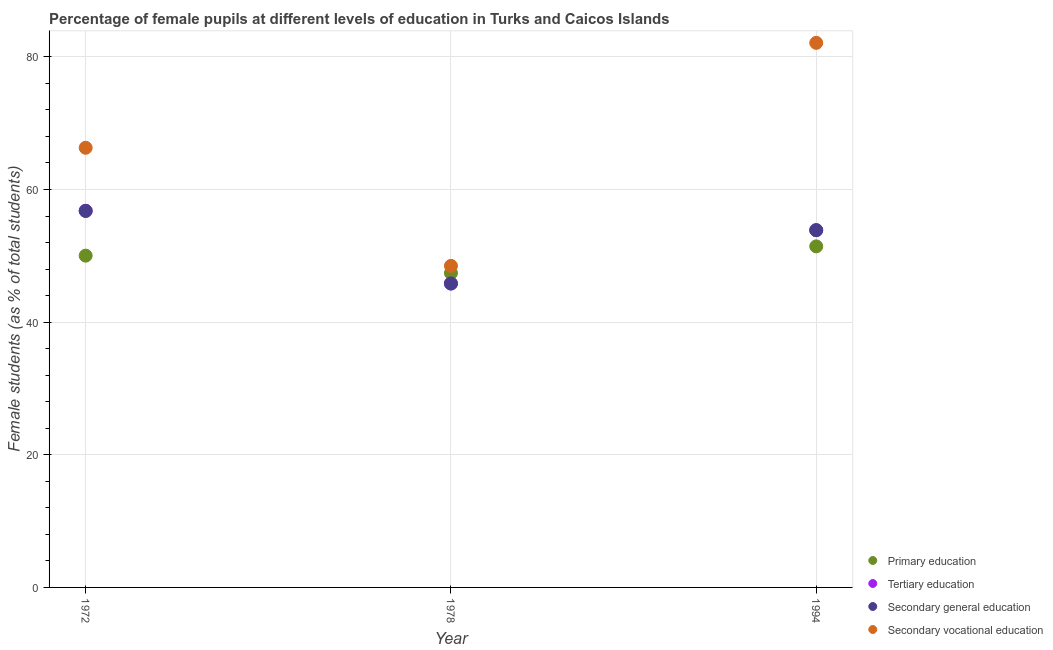How many different coloured dotlines are there?
Make the answer very short. 4. What is the percentage of female students in primary education in 1994?
Keep it short and to the point. 51.43. Across all years, what is the maximum percentage of female students in tertiary education?
Make the answer very short. 56.78. Across all years, what is the minimum percentage of female students in primary education?
Your response must be concise. 47.4. In which year was the percentage of female students in tertiary education minimum?
Offer a very short reply. 1978. What is the total percentage of female students in tertiary education in the graph?
Give a very brief answer. 156.47. What is the difference between the percentage of female students in tertiary education in 1972 and that in 1978?
Offer a very short reply. 10.96. What is the difference between the percentage of female students in tertiary education in 1978 and the percentage of female students in secondary education in 1994?
Your response must be concise. -8.04. What is the average percentage of female students in tertiary education per year?
Your response must be concise. 52.16. In the year 1994, what is the difference between the percentage of female students in primary education and percentage of female students in secondary education?
Make the answer very short. -2.44. In how many years, is the percentage of female students in secondary education greater than 64 %?
Make the answer very short. 0. What is the ratio of the percentage of female students in secondary education in 1972 to that in 1978?
Your response must be concise. 1.24. Is the percentage of female students in primary education in 1978 less than that in 1994?
Your answer should be compact. Yes. Is the difference between the percentage of female students in secondary vocational education in 1972 and 1978 greater than the difference between the percentage of female students in secondary education in 1972 and 1978?
Offer a terse response. Yes. What is the difference between the highest and the second highest percentage of female students in primary education?
Keep it short and to the point. 1.4. What is the difference between the highest and the lowest percentage of female students in primary education?
Keep it short and to the point. 4.03. Is the sum of the percentage of female students in primary education in 1978 and 1994 greater than the maximum percentage of female students in secondary vocational education across all years?
Your response must be concise. Yes. Is the percentage of female students in primary education strictly greater than the percentage of female students in secondary education over the years?
Provide a short and direct response. No. Is the percentage of female students in secondary education strictly less than the percentage of female students in tertiary education over the years?
Keep it short and to the point. No. How many dotlines are there?
Your response must be concise. 4. How many years are there in the graph?
Your response must be concise. 3. Are the values on the major ticks of Y-axis written in scientific E-notation?
Give a very brief answer. No. Does the graph contain any zero values?
Your response must be concise. No. What is the title of the graph?
Your response must be concise. Percentage of female pupils at different levels of education in Turks and Caicos Islands. What is the label or title of the X-axis?
Offer a terse response. Year. What is the label or title of the Y-axis?
Your answer should be compact. Female students (as % of total students). What is the Female students (as % of total students) in Primary education in 1972?
Offer a terse response. 50.03. What is the Female students (as % of total students) of Tertiary education in 1972?
Ensure brevity in your answer.  56.78. What is the Female students (as % of total students) of Secondary general education in 1972?
Your answer should be compact. 56.78. What is the Female students (as % of total students) in Secondary vocational education in 1972?
Offer a terse response. 66.29. What is the Female students (as % of total students) in Primary education in 1978?
Your response must be concise. 47.4. What is the Female students (as % of total students) of Tertiary education in 1978?
Offer a terse response. 45.82. What is the Female students (as % of total students) in Secondary general education in 1978?
Provide a succinct answer. 45.82. What is the Female students (as % of total students) of Secondary vocational education in 1978?
Give a very brief answer. 48.48. What is the Female students (as % of total students) of Primary education in 1994?
Provide a succinct answer. 51.43. What is the Female students (as % of total students) in Tertiary education in 1994?
Give a very brief answer. 53.87. What is the Female students (as % of total students) in Secondary general education in 1994?
Offer a very short reply. 53.87. What is the Female students (as % of total students) in Secondary vocational education in 1994?
Your answer should be very brief. 82.11. Across all years, what is the maximum Female students (as % of total students) of Primary education?
Give a very brief answer. 51.43. Across all years, what is the maximum Female students (as % of total students) of Tertiary education?
Your answer should be compact. 56.78. Across all years, what is the maximum Female students (as % of total students) of Secondary general education?
Provide a succinct answer. 56.78. Across all years, what is the maximum Female students (as % of total students) in Secondary vocational education?
Provide a succinct answer. 82.11. Across all years, what is the minimum Female students (as % of total students) of Primary education?
Your answer should be compact. 47.4. Across all years, what is the minimum Female students (as % of total students) in Tertiary education?
Give a very brief answer. 45.82. Across all years, what is the minimum Female students (as % of total students) in Secondary general education?
Offer a very short reply. 45.82. Across all years, what is the minimum Female students (as % of total students) of Secondary vocational education?
Offer a terse response. 48.48. What is the total Female students (as % of total students) in Primary education in the graph?
Offer a terse response. 148.86. What is the total Female students (as % of total students) of Tertiary education in the graph?
Keep it short and to the point. 156.47. What is the total Female students (as % of total students) of Secondary general education in the graph?
Offer a very short reply. 156.47. What is the total Female students (as % of total students) of Secondary vocational education in the graph?
Offer a terse response. 196.89. What is the difference between the Female students (as % of total students) in Primary education in 1972 and that in 1978?
Keep it short and to the point. 2.63. What is the difference between the Female students (as % of total students) in Tertiary education in 1972 and that in 1978?
Offer a terse response. 10.96. What is the difference between the Female students (as % of total students) in Secondary general education in 1972 and that in 1978?
Provide a short and direct response. 10.96. What is the difference between the Female students (as % of total students) of Secondary vocational education in 1972 and that in 1978?
Make the answer very short. 17.81. What is the difference between the Female students (as % of total students) of Primary education in 1972 and that in 1994?
Provide a succinct answer. -1.4. What is the difference between the Female students (as % of total students) in Tertiary education in 1972 and that in 1994?
Ensure brevity in your answer.  2.91. What is the difference between the Female students (as % of total students) of Secondary general education in 1972 and that in 1994?
Provide a short and direct response. 2.91. What is the difference between the Female students (as % of total students) of Secondary vocational education in 1972 and that in 1994?
Provide a succinct answer. -15.82. What is the difference between the Female students (as % of total students) of Primary education in 1978 and that in 1994?
Your answer should be compact. -4.03. What is the difference between the Female students (as % of total students) in Tertiary education in 1978 and that in 1994?
Your response must be concise. -8.04. What is the difference between the Female students (as % of total students) of Secondary general education in 1978 and that in 1994?
Offer a very short reply. -8.04. What is the difference between the Female students (as % of total students) in Secondary vocational education in 1978 and that in 1994?
Give a very brief answer. -33.63. What is the difference between the Female students (as % of total students) in Primary education in 1972 and the Female students (as % of total students) in Tertiary education in 1978?
Give a very brief answer. 4.2. What is the difference between the Female students (as % of total students) in Primary education in 1972 and the Female students (as % of total students) in Secondary general education in 1978?
Your answer should be compact. 4.2. What is the difference between the Female students (as % of total students) in Primary education in 1972 and the Female students (as % of total students) in Secondary vocational education in 1978?
Your response must be concise. 1.54. What is the difference between the Female students (as % of total students) in Tertiary education in 1972 and the Female students (as % of total students) in Secondary general education in 1978?
Ensure brevity in your answer.  10.96. What is the difference between the Female students (as % of total students) of Tertiary education in 1972 and the Female students (as % of total students) of Secondary vocational education in 1978?
Provide a succinct answer. 8.29. What is the difference between the Female students (as % of total students) in Secondary general education in 1972 and the Female students (as % of total students) in Secondary vocational education in 1978?
Make the answer very short. 8.29. What is the difference between the Female students (as % of total students) of Primary education in 1972 and the Female students (as % of total students) of Tertiary education in 1994?
Keep it short and to the point. -3.84. What is the difference between the Female students (as % of total students) of Primary education in 1972 and the Female students (as % of total students) of Secondary general education in 1994?
Provide a short and direct response. -3.84. What is the difference between the Female students (as % of total students) of Primary education in 1972 and the Female students (as % of total students) of Secondary vocational education in 1994?
Ensure brevity in your answer.  -32.09. What is the difference between the Female students (as % of total students) in Tertiary education in 1972 and the Female students (as % of total students) in Secondary general education in 1994?
Keep it short and to the point. 2.91. What is the difference between the Female students (as % of total students) in Tertiary education in 1972 and the Female students (as % of total students) in Secondary vocational education in 1994?
Offer a terse response. -25.33. What is the difference between the Female students (as % of total students) in Secondary general education in 1972 and the Female students (as % of total students) in Secondary vocational education in 1994?
Keep it short and to the point. -25.33. What is the difference between the Female students (as % of total students) in Primary education in 1978 and the Female students (as % of total students) in Tertiary education in 1994?
Provide a succinct answer. -6.47. What is the difference between the Female students (as % of total students) in Primary education in 1978 and the Female students (as % of total students) in Secondary general education in 1994?
Offer a terse response. -6.47. What is the difference between the Female students (as % of total students) in Primary education in 1978 and the Female students (as % of total students) in Secondary vocational education in 1994?
Your answer should be compact. -34.71. What is the difference between the Female students (as % of total students) of Tertiary education in 1978 and the Female students (as % of total students) of Secondary general education in 1994?
Offer a terse response. -8.04. What is the difference between the Female students (as % of total students) in Tertiary education in 1978 and the Female students (as % of total students) in Secondary vocational education in 1994?
Your answer should be compact. -36.29. What is the difference between the Female students (as % of total students) of Secondary general education in 1978 and the Female students (as % of total students) of Secondary vocational education in 1994?
Give a very brief answer. -36.29. What is the average Female students (as % of total students) of Primary education per year?
Ensure brevity in your answer.  49.62. What is the average Female students (as % of total students) in Tertiary education per year?
Offer a terse response. 52.16. What is the average Female students (as % of total students) in Secondary general education per year?
Give a very brief answer. 52.16. What is the average Female students (as % of total students) of Secondary vocational education per year?
Your answer should be very brief. 65.63. In the year 1972, what is the difference between the Female students (as % of total students) of Primary education and Female students (as % of total students) of Tertiary education?
Your answer should be very brief. -6.75. In the year 1972, what is the difference between the Female students (as % of total students) of Primary education and Female students (as % of total students) of Secondary general education?
Provide a short and direct response. -6.75. In the year 1972, what is the difference between the Female students (as % of total students) in Primary education and Female students (as % of total students) in Secondary vocational education?
Your answer should be very brief. -16.26. In the year 1972, what is the difference between the Female students (as % of total students) in Tertiary education and Female students (as % of total students) in Secondary general education?
Provide a succinct answer. 0. In the year 1972, what is the difference between the Female students (as % of total students) of Tertiary education and Female students (as % of total students) of Secondary vocational education?
Give a very brief answer. -9.51. In the year 1972, what is the difference between the Female students (as % of total students) of Secondary general education and Female students (as % of total students) of Secondary vocational education?
Provide a succinct answer. -9.51. In the year 1978, what is the difference between the Female students (as % of total students) of Primary education and Female students (as % of total students) of Tertiary education?
Provide a short and direct response. 1.58. In the year 1978, what is the difference between the Female students (as % of total students) in Primary education and Female students (as % of total students) in Secondary general education?
Provide a short and direct response. 1.58. In the year 1978, what is the difference between the Female students (as % of total students) in Primary education and Female students (as % of total students) in Secondary vocational education?
Your response must be concise. -1.09. In the year 1978, what is the difference between the Female students (as % of total students) in Tertiary education and Female students (as % of total students) in Secondary general education?
Give a very brief answer. 0. In the year 1978, what is the difference between the Female students (as % of total students) of Tertiary education and Female students (as % of total students) of Secondary vocational education?
Your answer should be compact. -2.66. In the year 1978, what is the difference between the Female students (as % of total students) of Secondary general education and Female students (as % of total students) of Secondary vocational education?
Provide a short and direct response. -2.66. In the year 1994, what is the difference between the Female students (as % of total students) in Primary education and Female students (as % of total students) in Tertiary education?
Make the answer very short. -2.44. In the year 1994, what is the difference between the Female students (as % of total students) in Primary education and Female students (as % of total students) in Secondary general education?
Keep it short and to the point. -2.44. In the year 1994, what is the difference between the Female students (as % of total students) in Primary education and Female students (as % of total students) in Secondary vocational education?
Provide a succinct answer. -30.69. In the year 1994, what is the difference between the Female students (as % of total students) of Tertiary education and Female students (as % of total students) of Secondary general education?
Your response must be concise. 0. In the year 1994, what is the difference between the Female students (as % of total students) in Tertiary education and Female students (as % of total students) in Secondary vocational education?
Make the answer very short. -28.25. In the year 1994, what is the difference between the Female students (as % of total students) of Secondary general education and Female students (as % of total students) of Secondary vocational education?
Provide a succinct answer. -28.25. What is the ratio of the Female students (as % of total students) of Primary education in 1972 to that in 1978?
Give a very brief answer. 1.06. What is the ratio of the Female students (as % of total students) of Tertiary education in 1972 to that in 1978?
Give a very brief answer. 1.24. What is the ratio of the Female students (as % of total students) of Secondary general education in 1972 to that in 1978?
Your response must be concise. 1.24. What is the ratio of the Female students (as % of total students) in Secondary vocational education in 1972 to that in 1978?
Offer a terse response. 1.37. What is the ratio of the Female students (as % of total students) of Primary education in 1972 to that in 1994?
Offer a very short reply. 0.97. What is the ratio of the Female students (as % of total students) in Tertiary education in 1972 to that in 1994?
Your answer should be very brief. 1.05. What is the ratio of the Female students (as % of total students) in Secondary general education in 1972 to that in 1994?
Ensure brevity in your answer.  1.05. What is the ratio of the Female students (as % of total students) of Secondary vocational education in 1972 to that in 1994?
Offer a terse response. 0.81. What is the ratio of the Female students (as % of total students) of Primary education in 1978 to that in 1994?
Your answer should be compact. 0.92. What is the ratio of the Female students (as % of total students) in Tertiary education in 1978 to that in 1994?
Give a very brief answer. 0.85. What is the ratio of the Female students (as % of total students) in Secondary general education in 1978 to that in 1994?
Offer a very short reply. 0.85. What is the ratio of the Female students (as % of total students) of Secondary vocational education in 1978 to that in 1994?
Give a very brief answer. 0.59. What is the difference between the highest and the second highest Female students (as % of total students) in Primary education?
Your answer should be compact. 1.4. What is the difference between the highest and the second highest Female students (as % of total students) in Tertiary education?
Offer a terse response. 2.91. What is the difference between the highest and the second highest Female students (as % of total students) of Secondary general education?
Your response must be concise. 2.91. What is the difference between the highest and the second highest Female students (as % of total students) of Secondary vocational education?
Offer a very short reply. 15.82. What is the difference between the highest and the lowest Female students (as % of total students) in Primary education?
Offer a terse response. 4.03. What is the difference between the highest and the lowest Female students (as % of total students) in Tertiary education?
Offer a very short reply. 10.96. What is the difference between the highest and the lowest Female students (as % of total students) of Secondary general education?
Provide a succinct answer. 10.96. What is the difference between the highest and the lowest Female students (as % of total students) in Secondary vocational education?
Offer a very short reply. 33.63. 